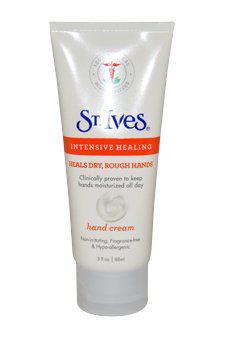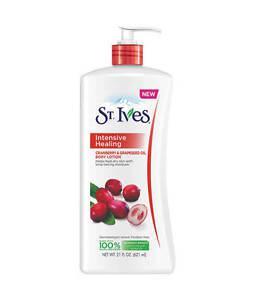The first image is the image on the left, the second image is the image on the right. Assess this claim about the two images: "One image shows exactly one pump-top product with the nozzle facing right, and the other image shows exactly one pump-top product with the nozzle facing left.". Correct or not? Answer yes or no. No. The first image is the image on the left, the second image is the image on the right. Given the left and right images, does the statement "Each image has one bottle of lotion with a pump top, both the same brand, but with different labels." hold true? Answer yes or no. No. 